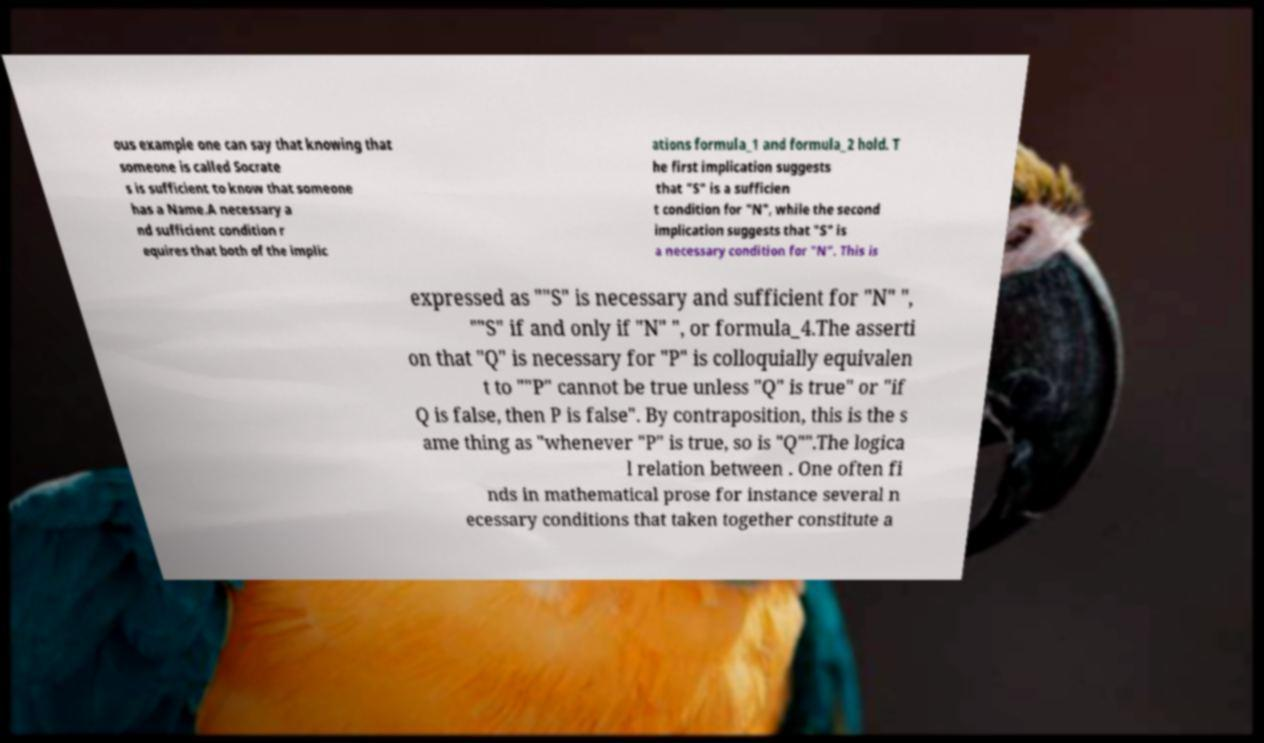Please read and relay the text visible in this image. What does it say? ous example one can say that knowing that someone is called Socrate s is sufficient to know that someone has a Name.A necessary a nd sufficient condition r equires that both of the implic ations formula_1 and formula_2 hold. T he first implication suggests that "S" is a sufficien t condition for "N", while the second implication suggests that "S" is a necessary condition for "N". This is expressed as ""S" is necessary and sufficient for "N" ", ""S" if and only if "N" ", or formula_4.The asserti on that "Q" is necessary for "P" is colloquially equivalen t to ""P" cannot be true unless "Q" is true" or "if Q is false, then P is false". By contraposition, this is the s ame thing as "whenever "P" is true, so is "Q"".The logica l relation between . One often fi nds in mathematical prose for instance several n ecessary conditions that taken together constitute a 